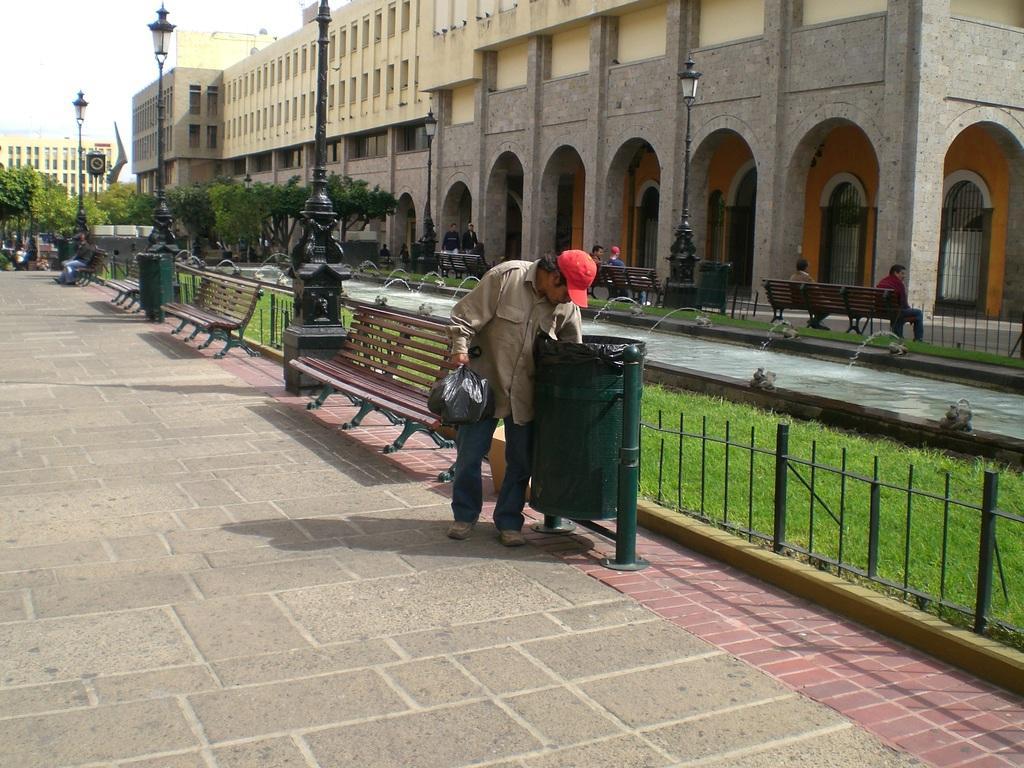In one or two sentences, can you explain what this image depicts? In this picture we can see a person is holding a polyethylene cover and on the right side of the person there is a dustbin. Behind the people there is a fence, benches and poles with lights. Some people are sitting on the benches and some people are walking. Behind the people there are trees, buildings and the sky. 